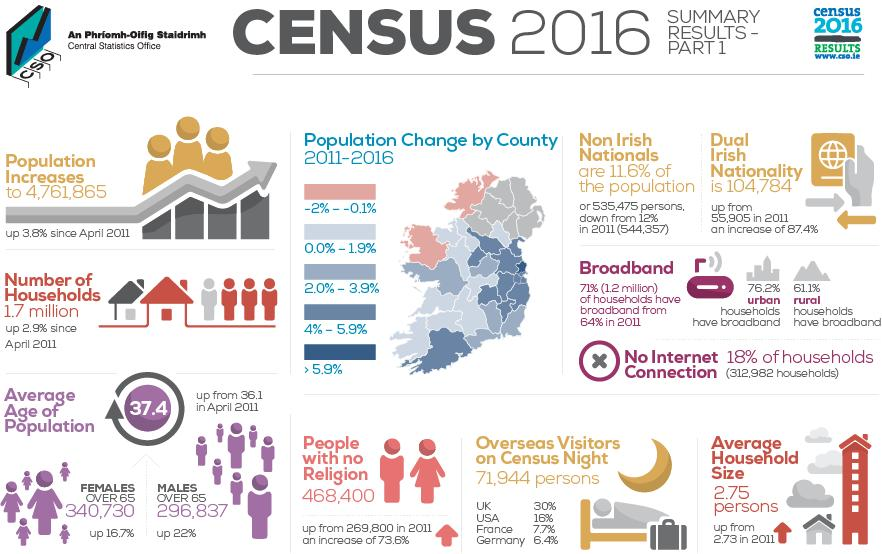Draw attention to some important aspects in this diagram. According to data from 2011, the percentage increase of people with no religion ranged from 6.4% to 7.7%, and it was reported to be 73.6%. During the period of 2011-2016, 2 counties in Ireland have experienced a decrease in population percentage change. According to the data provided, the percentage decrease in non-Irish nationals from the population since 2011 is 0.4%. Out of all the counties, how many have experienced a population growth rate of more than 5.9%? The percentage difference in urban and rural households having broadband is 15.1%. 